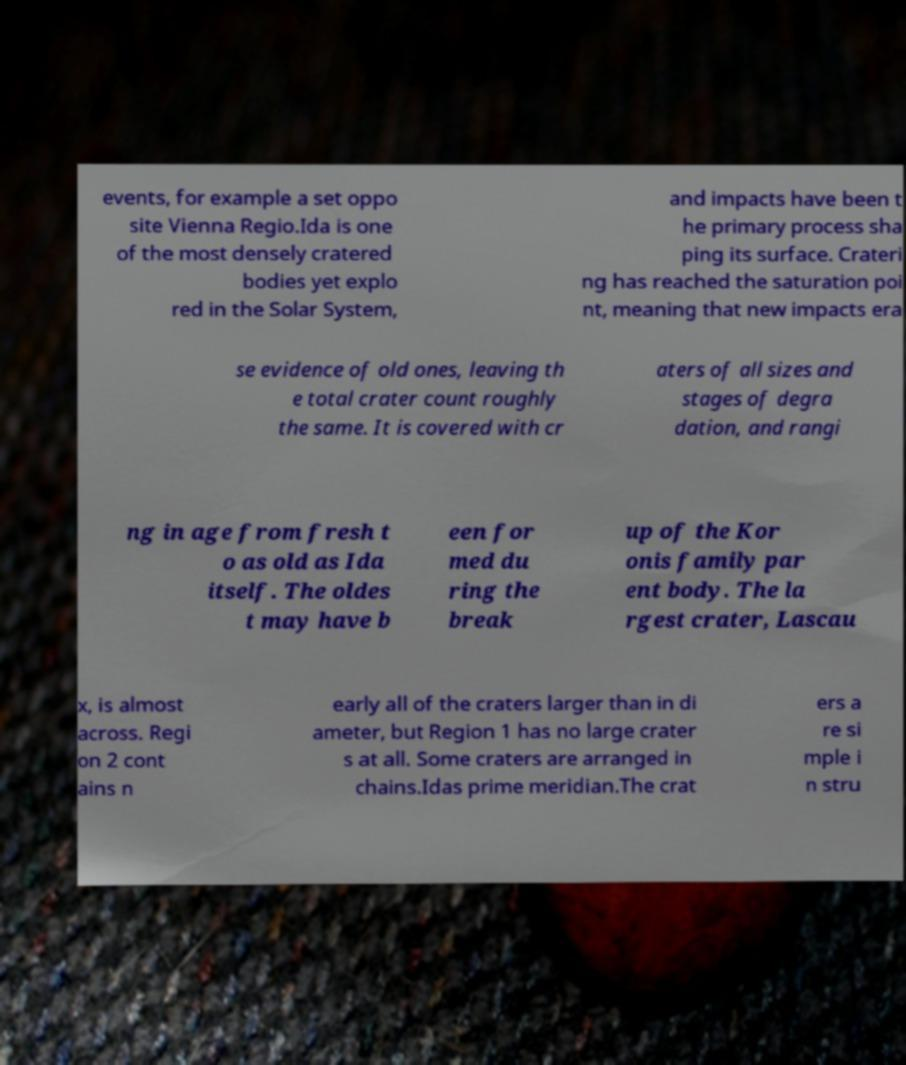Please read and relay the text visible in this image. What does it say? events, for example a set oppo site Vienna Regio.Ida is one of the most densely cratered bodies yet explo red in the Solar System, and impacts have been t he primary process sha ping its surface. Crateri ng has reached the saturation poi nt, meaning that new impacts era se evidence of old ones, leaving th e total crater count roughly the same. It is covered with cr aters of all sizes and stages of degra dation, and rangi ng in age from fresh t o as old as Ida itself. The oldes t may have b een for med du ring the break up of the Kor onis family par ent body. The la rgest crater, Lascau x, is almost across. Regi on 2 cont ains n early all of the craters larger than in di ameter, but Region 1 has no large crater s at all. Some craters are arranged in chains.Idas prime meridian.The crat ers a re si mple i n stru 